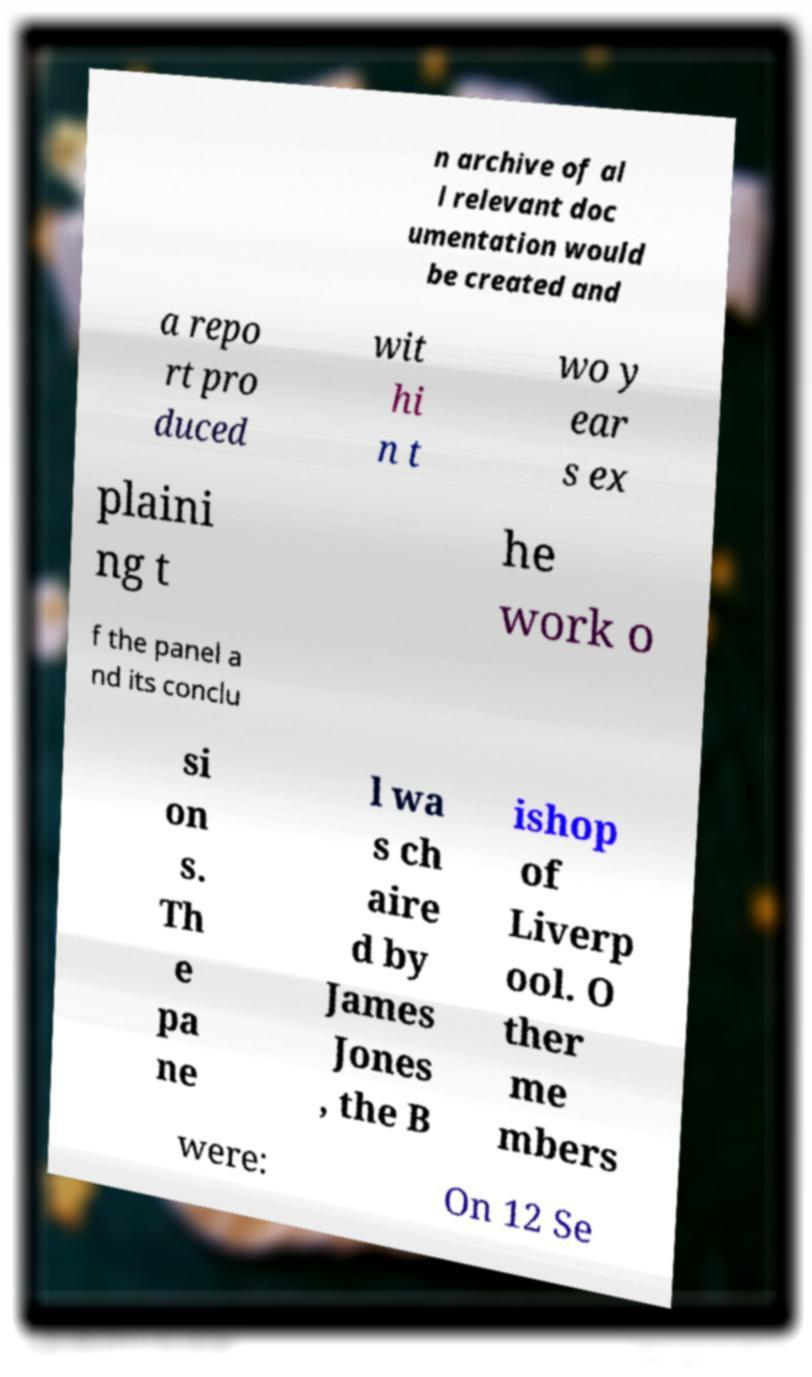For documentation purposes, I need the text within this image transcribed. Could you provide that? n archive of al l relevant doc umentation would be created and a repo rt pro duced wit hi n t wo y ear s ex plaini ng t he work o f the panel a nd its conclu si on s. Th e pa ne l wa s ch aire d by James Jones , the B ishop of Liverp ool. O ther me mbers were: On 12 Se 